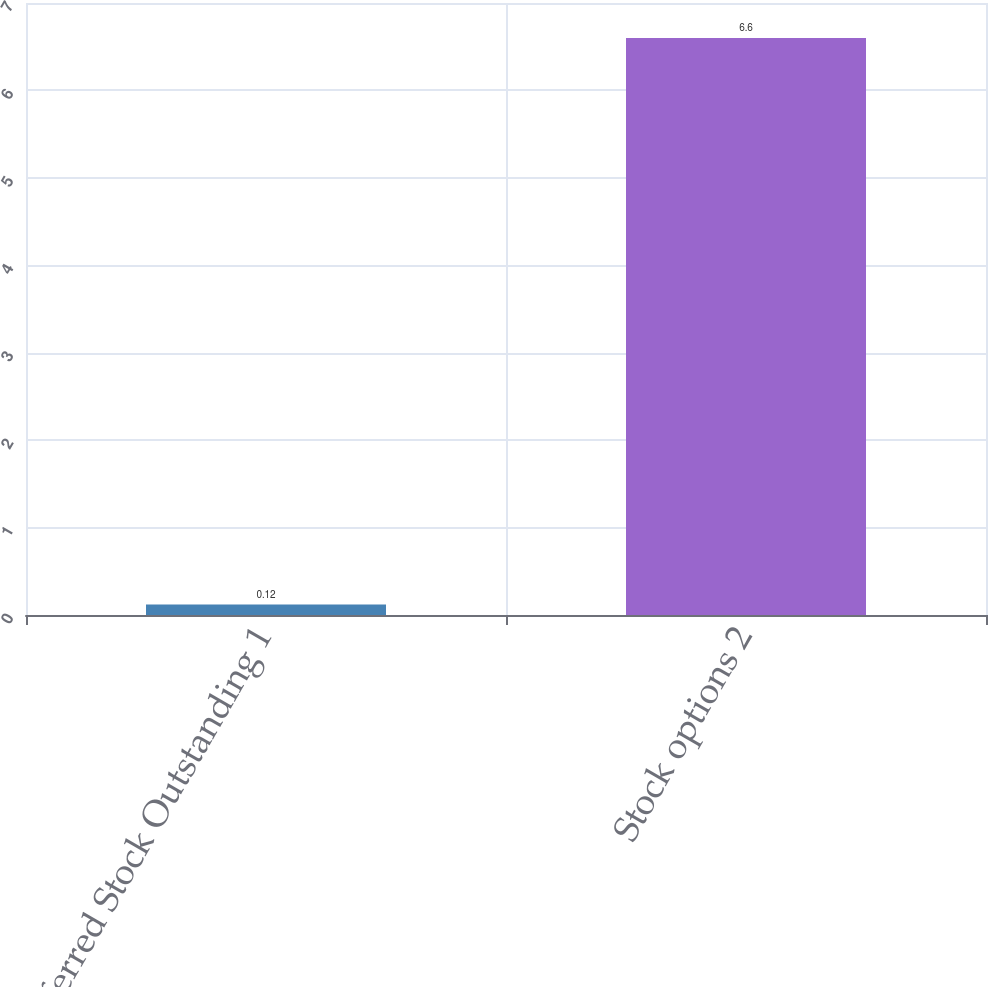Convert chart. <chart><loc_0><loc_0><loc_500><loc_500><bar_chart><fcel>Preferred Stock Outstanding 1<fcel>Stock options 2<nl><fcel>0.12<fcel>6.6<nl></chart> 